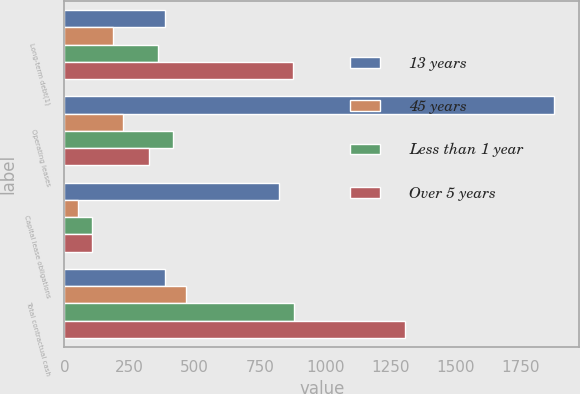Convert chart to OTSL. <chart><loc_0><loc_0><loc_500><loc_500><stacked_bar_chart><ecel><fcel>Long-term debt(1)<fcel>Operating leases<fcel>Capital lease obligations<fcel>Total contractual cash<nl><fcel>13 years<fcel>387.5<fcel>1880<fcel>823<fcel>387.5<nl><fcel>45 years<fcel>188<fcel>225<fcel>52<fcel>465<nl><fcel>Less than 1 year<fcel>357<fcel>418<fcel>104<fcel>879<nl><fcel>Over 5 years<fcel>877<fcel>324<fcel>104<fcel>1305<nl></chart> 